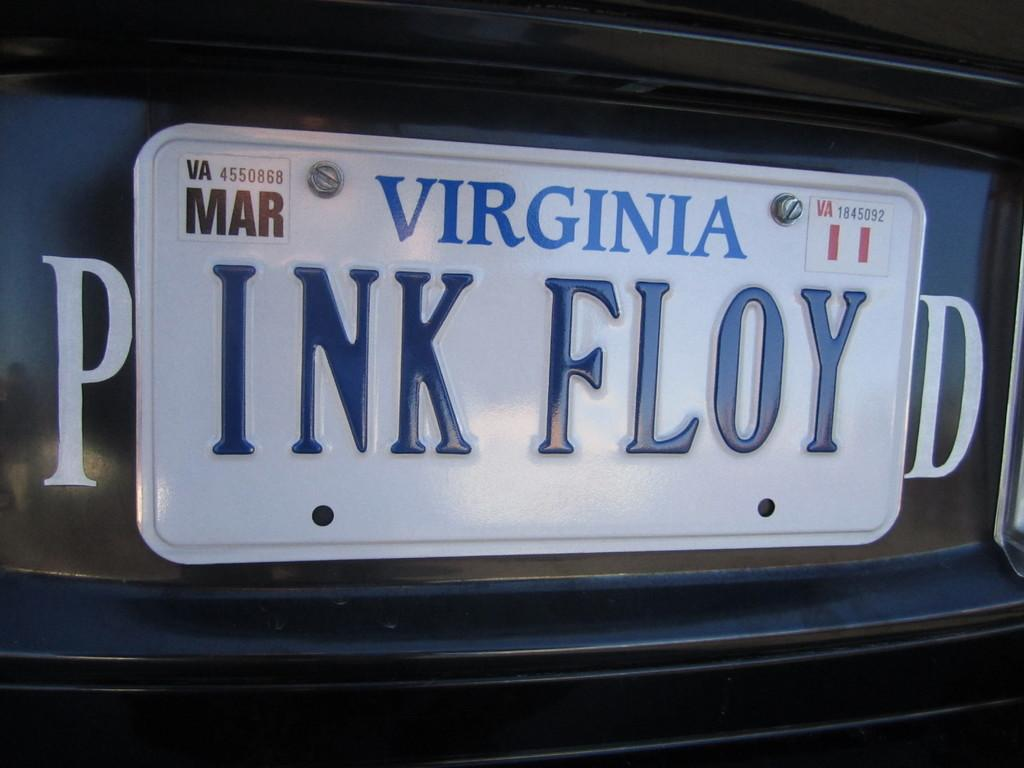<image>
Share a concise interpretation of the image provided. A Virginia vanity license plate reads "INK FLOY" and is positioned between a P and a D so it reads "PINK FLOYD." 